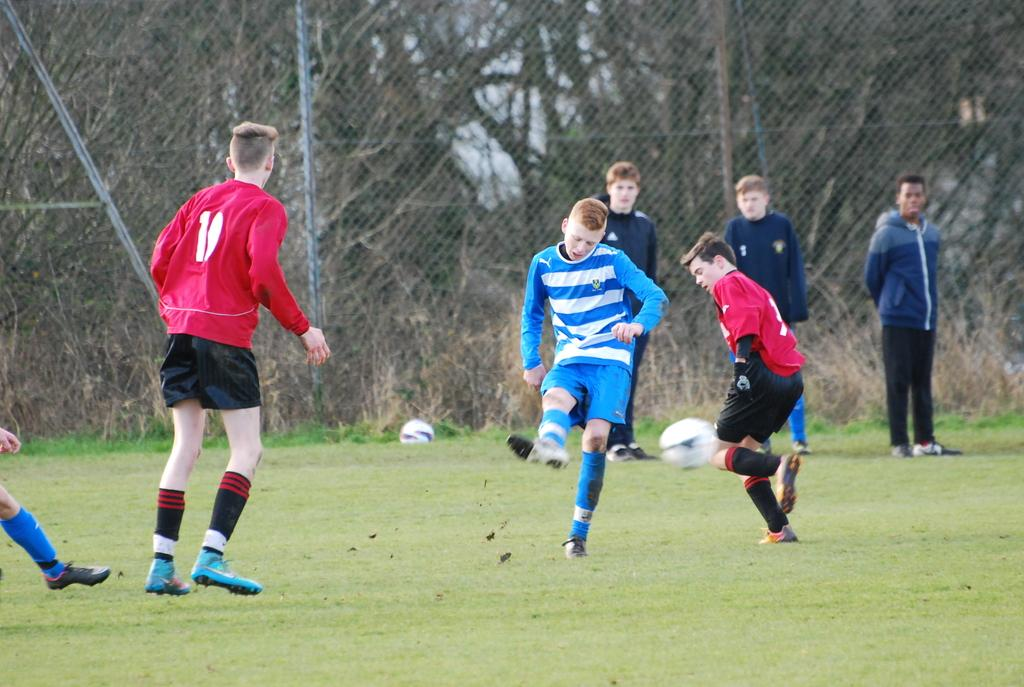How many people are in the image? There are three persons in the image. What are the three persons doing in the image? The three persons are walking, as indicated by leg movement. What can be seen in the background of the image? There are bare trees in the distance. What is the color of the grass in the image? The grass is green in color. What object is present in the image? There is a ball in the image. Are the three persons standing or sitting in the image? The three persons are standing. What type of dress is the person wearing in the image? There is no person wearing a dress in the image; all three persons are wearing pants or shorts. Can you tell me how many loaves of bread are visible in the image? There is no bread present in the image. 